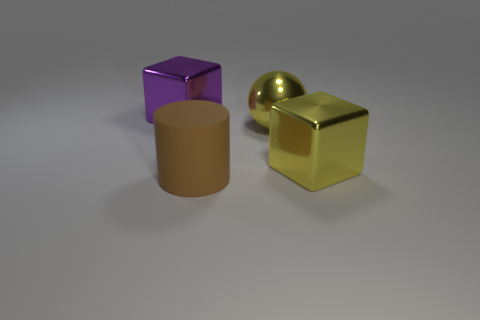Add 3 cyan metallic cylinders. How many objects exist? 7 Subtract all cylinders. How many objects are left? 3 Subtract all big metallic spheres. Subtract all large blue shiny cylinders. How many objects are left? 3 Add 1 large blocks. How many large blocks are left? 3 Add 2 small rubber cubes. How many small rubber cubes exist? 2 Subtract 0 gray cubes. How many objects are left? 4 